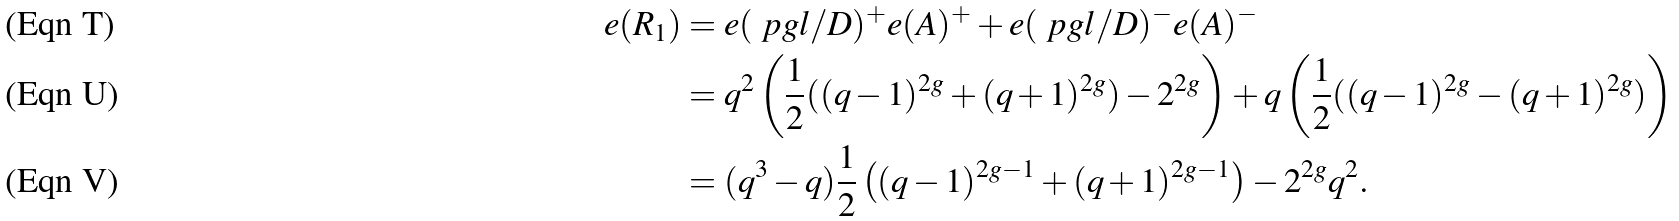<formula> <loc_0><loc_0><loc_500><loc_500>e ( R _ { 1 } ) & = e ( \ p g l / D ) ^ { + } e ( A ) ^ { + } + e ( \ p g l / D ) ^ { - } e ( A ) ^ { - } \\ & = q ^ { 2 } \left ( \frac { 1 } { 2 } ( ( q - 1 ) ^ { 2 g } + ( q + 1 ) ^ { 2 g } ) - 2 ^ { 2 g } \right ) + q \left ( \frac { 1 } { 2 } ( ( q - 1 ) ^ { 2 g } - ( q + 1 ) ^ { 2 g } ) \right ) \\ & = ( q ^ { 3 } - q ) \frac { 1 } { 2 } \left ( ( q - 1 ) ^ { 2 g - 1 } + ( q + 1 ) ^ { 2 g - 1 } \right ) - 2 ^ { 2 g } q ^ { 2 } .</formula> 